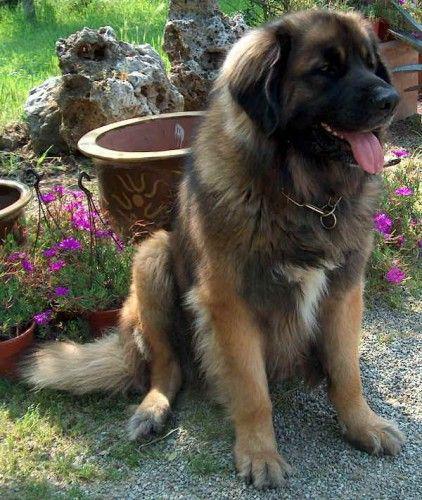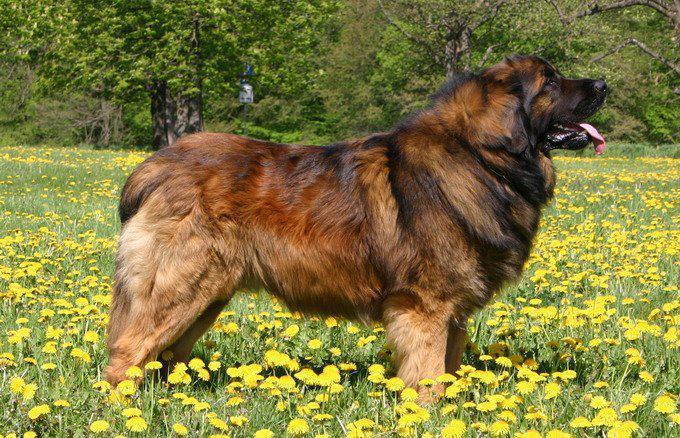The first image is the image on the left, the second image is the image on the right. For the images shown, is this caption "There are exactly two dogs in the left image." true? Answer yes or no. No. The first image is the image on the left, the second image is the image on the right. Given the left and right images, does the statement "One image includes a dog standing in profile, and the other image contains at least two dogs." hold true? Answer yes or no. No. 